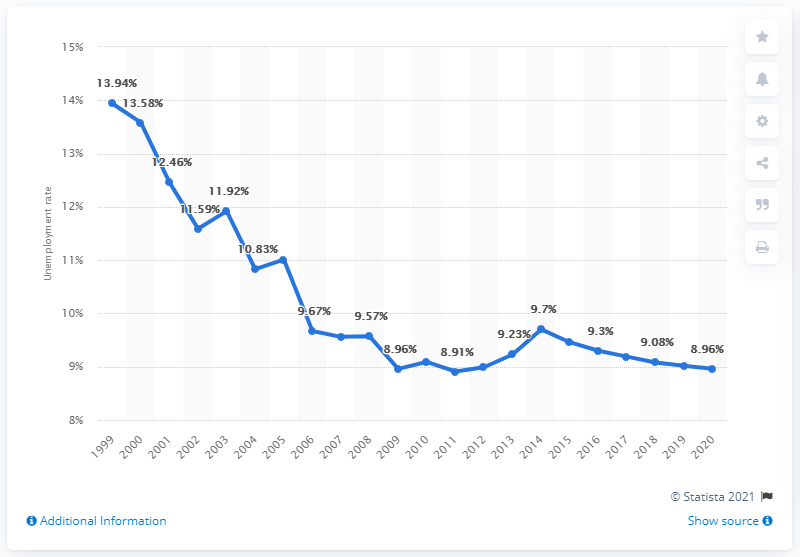Draw attention to some important aspects in this diagram. In 2020, the unemployment rate in Morocco was 8.96%. 